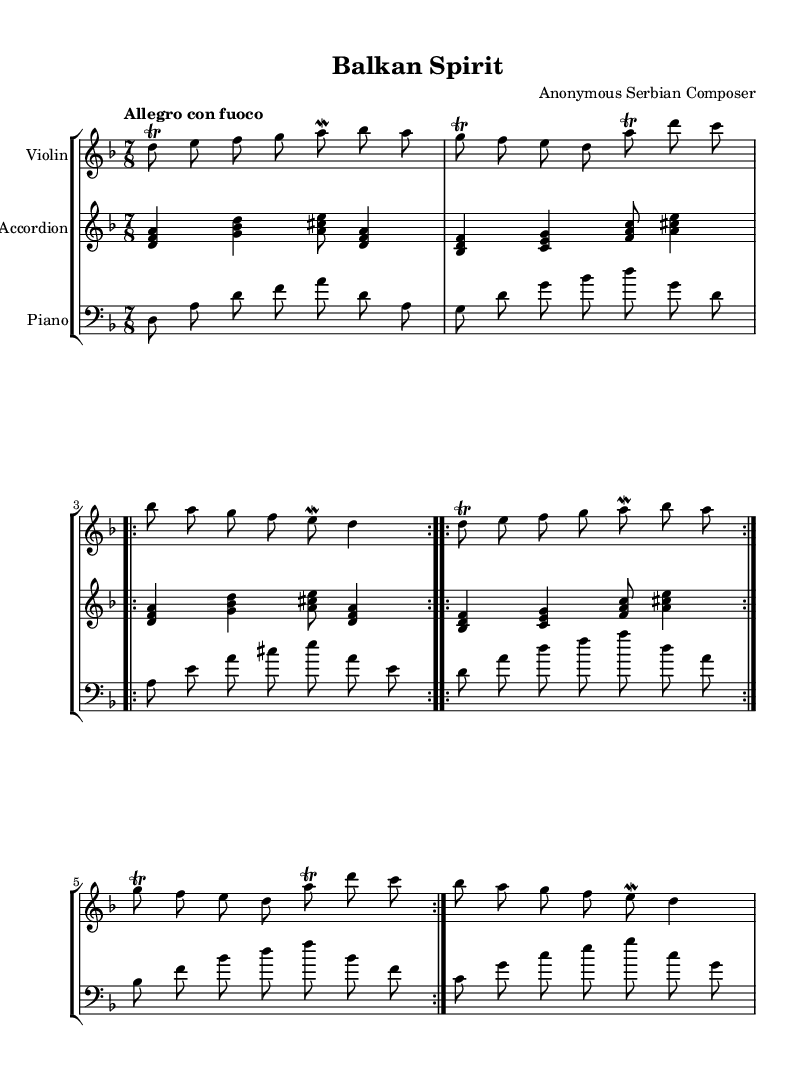What is the key signature of this music? The key signature is indicated at the beginning of the score. In this case, it shows one flat, which corresponds to D minor.
Answer: D minor What is the time signature of this piece? The time signature is shown at the beginning of the score right after the key signature. It is 7/8, indicating a compound meter with seven eighth notes per measure.
Answer: 7/8 What is the tempo marking for this composition? The tempo marking is specified near the beginning of the score. It reads "Allegro con fuoco," which translates to a fast tempo with fire or passion.
Answer: Allegro con fuoco How many times is the repeated section indicated? The repetition is noted in the score with the "repeat volta" instruction. It indicates that the previous section is played twice. Therefore, the value mentioned in the score is 2.
Answer: 2 What is the structure of the violin part in terms of phrases? The violin part contains multiple phrases, divided into sections separated by bar lines. Notably, the total structure has a repeat sign, indicating phrases are repeated within the context of the overall form. The phrases develop around trills and mordents, characteristic of Romantic folk-influenced music.
Answer: 3 phrases What instruments are included in this score? The score clearly indicates three parts: Violin, Accordion, and Piano, each represented in separate staves. This variety creates a rich texture typical of folk-inspired classical music.
Answer: Violin, Accordion, Piano What is a defining feature of the Romantic style in this composition? The use of ornamentation such as trills and mordents is a hallmark of the Romantic style, enhancing expressiveness. The lively tempo and complex rhythms also reflect the passionate nature typical of this genre, contributing to the piece's overall character.
Answer: Ornamentation 